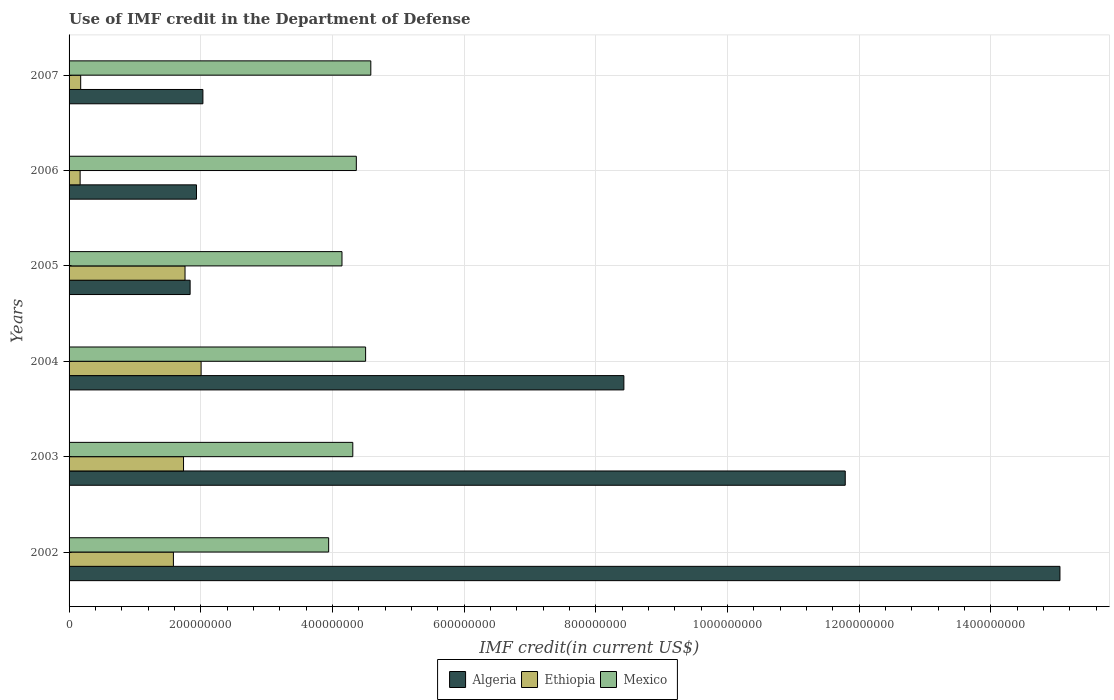How many different coloured bars are there?
Provide a short and direct response. 3. How many groups of bars are there?
Keep it short and to the point. 6. Are the number of bars on each tick of the Y-axis equal?
Make the answer very short. Yes. What is the label of the 1st group of bars from the top?
Ensure brevity in your answer.  2007. In how many cases, is the number of bars for a given year not equal to the number of legend labels?
Provide a succinct answer. 0. What is the IMF credit in the Department of Defense in Ethiopia in 2002?
Your answer should be very brief. 1.58e+08. Across all years, what is the maximum IMF credit in the Department of Defense in Algeria?
Ensure brevity in your answer.  1.51e+09. Across all years, what is the minimum IMF credit in the Department of Defense in Ethiopia?
Provide a short and direct response. 1.68e+07. In which year was the IMF credit in the Department of Defense in Ethiopia maximum?
Offer a terse response. 2004. In which year was the IMF credit in the Department of Defense in Ethiopia minimum?
Provide a succinct answer. 2006. What is the total IMF credit in the Department of Defense in Algeria in the graph?
Offer a terse response. 4.11e+09. What is the difference between the IMF credit in the Department of Defense in Ethiopia in 2002 and that in 2007?
Keep it short and to the point. 1.41e+08. What is the difference between the IMF credit in the Department of Defense in Algeria in 2004 and the IMF credit in the Department of Defense in Mexico in 2006?
Offer a terse response. 4.06e+08. What is the average IMF credit in the Department of Defense in Algeria per year?
Make the answer very short. 6.85e+08. In the year 2005, what is the difference between the IMF credit in the Department of Defense in Algeria and IMF credit in the Department of Defense in Mexico?
Offer a very short reply. -2.31e+08. What is the ratio of the IMF credit in the Department of Defense in Mexico in 2002 to that in 2005?
Offer a very short reply. 0.95. What is the difference between the highest and the second highest IMF credit in the Department of Defense in Algeria?
Ensure brevity in your answer.  3.26e+08. What is the difference between the highest and the lowest IMF credit in the Department of Defense in Algeria?
Give a very brief answer. 1.32e+09. In how many years, is the IMF credit in the Department of Defense in Mexico greater than the average IMF credit in the Department of Defense in Mexico taken over all years?
Your answer should be compact. 4. Is the sum of the IMF credit in the Department of Defense in Algeria in 2005 and 2006 greater than the maximum IMF credit in the Department of Defense in Mexico across all years?
Your answer should be very brief. No. What does the 2nd bar from the top in 2003 represents?
Your response must be concise. Ethiopia. What does the 3rd bar from the bottom in 2005 represents?
Give a very brief answer. Mexico. Is it the case that in every year, the sum of the IMF credit in the Department of Defense in Mexico and IMF credit in the Department of Defense in Algeria is greater than the IMF credit in the Department of Defense in Ethiopia?
Ensure brevity in your answer.  Yes. What is the difference between two consecutive major ticks on the X-axis?
Your answer should be very brief. 2.00e+08. Does the graph contain any zero values?
Provide a short and direct response. No. Where does the legend appear in the graph?
Provide a succinct answer. Bottom center. What is the title of the graph?
Give a very brief answer. Use of IMF credit in the Department of Defense. Does "Burundi" appear as one of the legend labels in the graph?
Your answer should be compact. No. What is the label or title of the X-axis?
Give a very brief answer. IMF credit(in current US$). What is the IMF credit(in current US$) of Algeria in 2002?
Your answer should be compact. 1.51e+09. What is the IMF credit(in current US$) in Ethiopia in 2002?
Ensure brevity in your answer.  1.58e+08. What is the IMF credit(in current US$) of Mexico in 2002?
Offer a very short reply. 3.94e+08. What is the IMF credit(in current US$) in Algeria in 2003?
Provide a short and direct response. 1.18e+09. What is the IMF credit(in current US$) of Ethiopia in 2003?
Offer a terse response. 1.74e+08. What is the IMF credit(in current US$) in Mexico in 2003?
Provide a succinct answer. 4.31e+08. What is the IMF credit(in current US$) of Algeria in 2004?
Your answer should be very brief. 8.43e+08. What is the IMF credit(in current US$) of Ethiopia in 2004?
Your answer should be very brief. 2.01e+08. What is the IMF credit(in current US$) of Mexico in 2004?
Provide a succinct answer. 4.50e+08. What is the IMF credit(in current US$) in Algeria in 2005?
Make the answer very short. 1.84e+08. What is the IMF credit(in current US$) of Ethiopia in 2005?
Give a very brief answer. 1.76e+08. What is the IMF credit(in current US$) in Mexico in 2005?
Offer a terse response. 4.15e+08. What is the IMF credit(in current US$) in Algeria in 2006?
Your answer should be compact. 1.94e+08. What is the IMF credit(in current US$) of Ethiopia in 2006?
Give a very brief answer. 1.68e+07. What is the IMF credit(in current US$) in Mexico in 2006?
Make the answer very short. 4.36e+08. What is the IMF credit(in current US$) in Algeria in 2007?
Offer a terse response. 2.03e+08. What is the IMF credit(in current US$) in Ethiopia in 2007?
Ensure brevity in your answer.  1.76e+07. What is the IMF credit(in current US$) of Mexico in 2007?
Your response must be concise. 4.58e+08. Across all years, what is the maximum IMF credit(in current US$) in Algeria?
Your answer should be compact. 1.51e+09. Across all years, what is the maximum IMF credit(in current US$) of Ethiopia?
Provide a short and direct response. 2.01e+08. Across all years, what is the maximum IMF credit(in current US$) of Mexico?
Make the answer very short. 4.58e+08. Across all years, what is the minimum IMF credit(in current US$) of Algeria?
Ensure brevity in your answer.  1.84e+08. Across all years, what is the minimum IMF credit(in current US$) in Ethiopia?
Your answer should be very brief. 1.68e+07. Across all years, what is the minimum IMF credit(in current US$) in Mexico?
Make the answer very short. 3.94e+08. What is the total IMF credit(in current US$) in Algeria in the graph?
Keep it short and to the point. 4.11e+09. What is the total IMF credit(in current US$) of Ethiopia in the graph?
Provide a short and direct response. 7.43e+08. What is the total IMF credit(in current US$) in Mexico in the graph?
Make the answer very short. 2.58e+09. What is the difference between the IMF credit(in current US$) of Algeria in 2002 and that in 2003?
Your answer should be compact. 3.26e+08. What is the difference between the IMF credit(in current US$) in Ethiopia in 2002 and that in 2003?
Keep it short and to the point. -1.54e+07. What is the difference between the IMF credit(in current US$) in Mexico in 2002 and that in 2003?
Offer a terse response. -3.67e+07. What is the difference between the IMF credit(in current US$) in Algeria in 2002 and that in 2004?
Your answer should be compact. 6.62e+08. What is the difference between the IMF credit(in current US$) of Ethiopia in 2002 and that in 2004?
Your answer should be compact. -4.21e+07. What is the difference between the IMF credit(in current US$) in Mexico in 2002 and that in 2004?
Ensure brevity in your answer.  -5.61e+07. What is the difference between the IMF credit(in current US$) of Algeria in 2002 and that in 2005?
Keep it short and to the point. 1.32e+09. What is the difference between the IMF credit(in current US$) in Ethiopia in 2002 and that in 2005?
Your response must be concise. -1.76e+07. What is the difference between the IMF credit(in current US$) of Mexico in 2002 and that in 2005?
Your answer should be very brief. -2.02e+07. What is the difference between the IMF credit(in current US$) in Algeria in 2002 and that in 2006?
Your response must be concise. 1.31e+09. What is the difference between the IMF credit(in current US$) of Ethiopia in 2002 and that in 2006?
Your answer should be compact. 1.42e+08. What is the difference between the IMF credit(in current US$) in Mexico in 2002 and that in 2006?
Make the answer very short. -4.20e+07. What is the difference between the IMF credit(in current US$) in Algeria in 2002 and that in 2007?
Ensure brevity in your answer.  1.30e+09. What is the difference between the IMF credit(in current US$) of Ethiopia in 2002 and that in 2007?
Your answer should be compact. 1.41e+08. What is the difference between the IMF credit(in current US$) of Mexico in 2002 and that in 2007?
Keep it short and to the point. -6.40e+07. What is the difference between the IMF credit(in current US$) in Algeria in 2003 and that in 2004?
Offer a terse response. 3.36e+08. What is the difference between the IMF credit(in current US$) of Ethiopia in 2003 and that in 2004?
Ensure brevity in your answer.  -2.67e+07. What is the difference between the IMF credit(in current US$) of Mexico in 2003 and that in 2004?
Provide a succinct answer. -1.94e+07. What is the difference between the IMF credit(in current US$) in Algeria in 2003 and that in 2005?
Provide a short and direct response. 9.95e+08. What is the difference between the IMF credit(in current US$) in Ethiopia in 2003 and that in 2005?
Your answer should be compact. -2.28e+06. What is the difference between the IMF credit(in current US$) of Mexico in 2003 and that in 2005?
Offer a very short reply. 1.64e+07. What is the difference between the IMF credit(in current US$) in Algeria in 2003 and that in 2006?
Your answer should be very brief. 9.85e+08. What is the difference between the IMF credit(in current US$) of Ethiopia in 2003 and that in 2006?
Ensure brevity in your answer.  1.57e+08. What is the difference between the IMF credit(in current US$) in Mexico in 2003 and that in 2006?
Make the answer very short. -5.34e+06. What is the difference between the IMF credit(in current US$) of Algeria in 2003 and that in 2007?
Ensure brevity in your answer.  9.76e+08. What is the difference between the IMF credit(in current US$) of Ethiopia in 2003 and that in 2007?
Offer a terse response. 1.56e+08. What is the difference between the IMF credit(in current US$) in Mexico in 2003 and that in 2007?
Your response must be concise. -2.73e+07. What is the difference between the IMF credit(in current US$) of Algeria in 2004 and that in 2005?
Your answer should be compact. 6.59e+08. What is the difference between the IMF credit(in current US$) in Ethiopia in 2004 and that in 2005?
Your answer should be compact. 2.44e+07. What is the difference between the IMF credit(in current US$) in Mexico in 2004 and that in 2005?
Your answer should be very brief. 3.59e+07. What is the difference between the IMF credit(in current US$) of Algeria in 2004 and that in 2006?
Give a very brief answer. 6.49e+08. What is the difference between the IMF credit(in current US$) in Ethiopia in 2004 and that in 2006?
Keep it short and to the point. 1.84e+08. What is the difference between the IMF credit(in current US$) in Mexico in 2004 and that in 2006?
Ensure brevity in your answer.  1.41e+07. What is the difference between the IMF credit(in current US$) in Algeria in 2004 and that in 2007?
Provide a succinct answer. 6.39e+08. What is the difference between the IMF credit(in current US$) of Ethiopia in 2004 and that in 2007?
Make the answer very short. 1.83e+08. What is the difference between the IMF credit(in current US$) of Mexico in 2004 and that in 2007?
Offer a very short reply. -7.90e+06. What is the difference between the IMF credit(in current US$) of Algeria in 2005 and that in 2006?
Your answer should be very brief. -9.66e+06. What is the difference between the IMF credit(in current US$) in Ethiopia in 2005 and that in 2006?
Offer a terse response. 1.59e+08. What is the difference between the IMF credit(in current US$) of Mexico in 2005 and that in 2006?
Your answer should be compact. -2.18e+07. What is the difference between the IMF credit(in current US$) in Algeria in 2005 and that in 2007?
Keep it short and to the point. -1.94e+07. What is the difference between the IMF credit(in current US$) of Ethiopia in 2005 and that in 2007?
Offer a terse response. 1.58e+08. What is the difference between the IMF credit(in current US$) in Mexico in 2005 and that in 2007?
Your answer should be very brief. -4.38e+07. What is the difference between the IMF credit(in current US$) of Algeria in 2006 and that in 2007?
Make the answer very short. -9.76e+06. What is the difference between the IMF credit(in current US$) in Ethiopia in 2006 and that in 2007?
Offer a very short reply. -8.47e+05. What is the difference between the IMF credit(in current US$) in Mexico in 2006 and that in 2007?
Provide a short and direct response. -2.20e+07. What is the difference between the IMF credit(in current US$) in Algeria in 2002 and the IMF credit(in current US$) in Ethiopia in 2003?
Your response must be concise. 1.33e+09. What is the difference between the IMF credit(in current US$) in Algeria in 2002 and the IMF credit(in current US$) in Mexico in 2003?
Provide a short and direct response. 1.07e+09. What is the difference between the IMF credit(in current US$) in Ethiopia in 2002 and the IMF credit(in current US$) in Mexico in 2003?
Give a very brief answer. -2.72e+08. What is the difference between the IMF credit(in current US$) in Algeria in 2002 and the IMF credit(in current US$) in Ethiopia in 2004?
Give a very brief answer. 1.30e+09. What is the difference between the IMF credit(in current US$) of Algeria in 2002 and the IMF credit(in current US$) of Mexico in 2004?
Your answer should be very brief. 1.05e+09. What is the difference between the IMF credit(in current US$) of Ethiopia in 2002 and the IMF credit(in current US$) of Mexico in 2004?
Provide a short and direct response. -2.92e+08. What is the difference between the IMF credit(in current US$) in Algeria in 2002 and the IMF credit(in current US$) in Ethiopia in 2005?
Offer a very short reply. 1.33e+09. What is the difference between the IMF credit(in current US$) in Algeria in 2002 and the IMF credit(in current US$) in Mexico in 2005?
Your response must be concise. 1.09e+09. What is the difference between the IMF credit(in current US$) of Ethiopia in 2002 and the IMF credit(in current US$) of Mexico in 2005?
Your answer should be compact. -2.56e+08. What is the difference between the IMF credit(in current US$) in Algeria in 2002 and the IMF credit(in current US$) in Ethiopia in 2006?
Provide a short and direct response. 1.49e+09. What is the difference between the IMF credit(in current US$) in Algeria in 2002 and the IMF credit(in current US$) in Mexico in 2006?
Your answer should be compact. 1.07e+09. What is the difference between the IMF credit(in current US$) of Ethiopia in 2002 and the IMF credit(in current US$) of Mexico in 2006?
Your answer should be very brief. -2.78e+08. What is the difference between the IMF credit(in current US$) in Algeria in 2002 and the IMF credit(in current US$) in Ethiopia in 2007?
Your answer should be very brief. 1.49e+09. What is the difference between the IMF credit(in current US$) in Algeria in 2002 and the IMF credit(in current US$) in Mexico in 2007?
Offer a very short reply. 1.05e+09. What is the difference between the IMF credit(in current US$) of Ethiopia in 2002 and the IMF credit(in current US$) of Mexico in 2007?
Give a very brief answer. -3.00e+08. What is the difference between the IMF credit(in current US$) of Algeria in 2003 and the IMF credit(in current US$) of Ethiopia in 2004?
Make the answer very short. 9.78e+08. What is the difference between the IMF credit(in current US$) in Algeria in 2003 and the IMF credit(in current US$) in Mexico in 2004?
Give a very brief answer. 7.29e+08. What is the difference between the IMF credit(in current US$) in Ethiopia in 2003 and the IMF credit(in current US$) in Mexico in 2004?
Your answer should be very brief. -2.77e+08. What is the difference between the IMF credit(in current US$) in Algeria in 2003 and the IMF credit(in current US$) in Ethiopia in 2005?
Offer a very short reply. 1.00e+09. What is the difference between the IMF credit(in current US$) in Algeria in 2003 and the IMF credit(in current US$) in Mexico in 2005?
Your answer should be compact. 7.64e+08. What is the difference between the IMF credit(in current US$) in Ethiopia in 2003 and the IMF credit(in current US$) in Mexico in 2005?
Your answer should be very brief. -2.41e+08. What is the difference between the IMF credit(in current US$) of Algeria in 2003 and the IMF credit(in current US$) of Ethiopia in 2006?
Provide a short and direct response. 1.16e+09. What is the difference between the IMF credit(in current US$) of Algeria in 2003 and the IMF credit(in current US$) of Mexico in 2006?
Provide a succinct answer. 7.43e+08. What is the difference between the IMF credit(in current US$) in Ethiopia in 2003 and the IMF credit(in current US$) in Mexico in 2006?
Provide a succinct answer. -2.62e+08. What is the difference between the IMF credit(in current US$) of Algeria in 2003 and the IMF credit(in current US$) of Ethiopia in 2007?
Your answer should be very brief. 1.16e+09. What is the difference between the IMF credit(in current US$) in Algeria in 2003 and the IMF credit(in current US$) in Mexico in 2007?
Offer a terse response. 7.21e+08. What is the difference between the IMF credit(in current US$) of Ethiopia in 2003 and the IMF credit(in current US$) of Mexico in 2007?
Your answer should be compact. -2.84e+08. What is the difference between the IMF credit(in current US$) of Algeria in 2004 and the IMF credit(in current US$) of Ethiopia in 2005?
Give a very brief answer. 6.67e+08. What is the difference between the IMF credit(in current US$) of Algeria in 2004 and the IMF credit(in current US$) of Mexico in 2005?
Give a very brief answer. 4.28e+08. What is the difference between the IMF credit(in current US$) in Ethiopia in 2004 and the IMF credit(in current US$) in Mexico in 2005?
Your answer should be very brief. -2.14e+08. What is the difference between the IMF credit(in current US$) in Algeria in 2004 and the IMF credit(in current US$) in Ethiopia in 2006?
Keep it short and to the point. 8.26e+08. What is the difference between the IMF credit(in current US$) in Algeria in 2004 and the IMF credit(in current US$) in Mexico in 2006?
Offer a terse response. 4.06e+08. What is the difference between the IMF credit(in current US$) of Ethiopia in 2004 and the IMF credit(in current US$) of Mexico in 2006?
Offer a terse response. -2.36e+08. What is the difference between the IMF credit(in current US$) of Algeria in 2004 and the IMF credit(in current US$) of Ethiopia in 2007?
Provide a short and direct response. 8.25e+08. What is the difference between the IMF credit(in current US$) in Algeria in 2004 and the IMF credit(in current US$) in Mexico in 2007?
Your answer should be compact. 3.84e+08. What is the difference between the IMF credit(in current US$) in Ethiopia in 2004 and the IMF credit(in current US$) in Mexico in 2007?
Make the answer very short. -2.58e+08. What is the difference between the IMF credit(in current US$) in Algeria in 2005 and the IMF credit(in current US$) in Ethiopia in 2006?
Your answer should be compact. 1.67e+08. What is the difference between the IMF credit(in current US$) of Algeria in 2005 and the IMF credit(in current US$) of Mexico in 2006?
Your response must be concise. -2.52e+08. What is the difference between the IMF credit(in current US$) in Ethiopia in 2005 and the IMF credit(in current US$) in Mexico in 2006?
Provide a succinct answer. -2.60e+08. What is the difference between the IMF credit(in current US$) in Algeria in 2005 and the IMF credit(in current US$) in Ethiopia in 2007?
Offer a terse response. 1.66e+08. What is the difference between the IMF credit(in current US$) in Algeria in 2005 and the IMF credit(in current US$) in Mexico in 2007?
Offer a terse response. -2.74e+08. What is the difference between the IMF credit(in current US$) of Ethiopia in 2005 and the IMF credit(in current US$) of Mexico in 2007?
Your answer should be compact. -2.82e+08. What is the difference between the IMF credit(in current US$) in Algeria in 2006 and the IMF credit(in current US$) in Ethiopia in 2007?
Ensure brevity in your answer.  1.76e+08. What is the difference between the IMF credit(in current US$) of Algeria in 2006 and the IMF credit(in current US$) of Mexico in 2007?
Provide a short and direct response. -2.65e+08. What is the difference between the IMF credit(in current US$) in Ethiopia in 2006 and the IMF credit(in current US$) in Mexico in 2007?
Make the answer very short. -4.42e+08. What is the average IMF credit(in current US$) of Algeria per year?
Your answer should be very brief. 6.85e+08. What is the average IMF credit(in current US$) in Ethiopia per year?
Keep it short and to the point. 1.24e+08. What is the average IMF credit(in current US$) of Mexico per year?
Give a very brief answer. 4.31e+08. In the year 2002, what is the difference between the IMF credit(in current US$) in Algeria and IMF credit(in current US$) in Ethiopia?
Give a very brief answer. 1.35e+09. In the year 2002, what is the difference between the IMF credit(in current US$) in Algeria and IMF credit(in current US$) in Mexico?
Your response must be concise. 1.11e+09. In the year 2002, what is the difference between the IMF credit(in current US$) in Ethiopia and IMF credit(in current US$) in Mexico?
Offer a terse response. -2.36e+08. In the year 2003, what is the difference between the IMF credit(in current US$) in Algeria and IMF credit(in current US$) in Ethiopia?
Provide a short and direct response. 1.01e+09. In the year 2003, what is the difference between the IMF credit(in current US$) in Algeria and IMF credit(in current US$) in Mexico?
Your answer should be very brief. 7.48e+08. In the year 2003, what is the difference between the IMF credit(in current US$) in Ethiopia and IMF credit(in current US$) in Mexico?
Ensure brevity in your answer.  -2.57e+08. In the year 2004, what is the difference between the IMF credit(in current US$) in Algeria and IMF credit(in current US$) in Ethiopia?
Your answer should be compact. 6.42e+08. In the year 2004, what is the difference between the IMF credit(in current US$) of Algeria and IMF credit(in current US$) of Mexico?
Your answer should be very brief. 3.92e+08. In the year 2004, what is the difference between the IMF credit(in current US$) of Ethiopia and IMF credit(in current US$) of Mexico?
Your response must be concise. -2.50e+08. In the year 2005, what is the difference between the IMF credit(in current US$) in Algeria and IMF credit(in current US$) in Ethiopia?
Your answer should be compact. 7.73e+06. In the year 2005, what is the difference between the IMF credit(in current US$) of Algeria and IMF credit(in current US$) of Mexico?
Make the answer very short. -2.31e+08. In the year 2005, what is the difference between the IMF credit(in current US$) in Ethiopia and IMF credit(in current US$) in Mexico?
Provide a short and direct response. -2.38e+08. In the year 2006, what is the difference between the IMF credit(in current US$) of Algeria and IMF credit(in current US$) of Ethiopia?
Your answer should be compact. 1.77e+08. In the year 2006, what is the difference between the IMF credit(in current US$) of Algeria and IMF credit(in current US$) of Mexico?
Give a very brief answer. -2.43e+08. In the year 2006, what is the difference between the IMF credit(in current US$) in Ethiopia and IMF credit(in current US$) in Mexico?
Your response must be concise. -4.20e+08. In the year 2007, what is the difference between the IMF credit(in current US$) of Algeria and IMF credit(in current US$) of Ethiopia?
Provide a succinct answer. 1.86e+08. In the year 2007, what is the difference between the IMF credit(in current US$) of Algeria and IMF credit(in current US$) of Mexico?
Provide a succinct answer. -2.55e+08. In the year 2007, what is the difference between the IMF credit(in current US$) in Ethiopia and IMF credit(in current US$) in Mexico?
Keep it short and to the point. -4.41e+08. What is the ratio of the IMF credit(in current US$) in Algeria in 2002 to that in 2003?
Your response must be concise. 1.28. What is the ratio of the IMF credit(in current US$) in Ethiopia in 2002 to that in 2003?
Provide a short and direct response. 0.91. What is the ratio of the IMF credit(in current US$) of Mexico in 2002 to that in 2003?
Give a very brief answer. 0.91. What is the ratio of the IMF credit(in current US$) of Algeria in 2002 to that in 2004?
Your response must be concise. 1.79. What is the ratio of the IMF credit(in current US$) in Ethiopia in 2002 to that in 2004?
Ensure brevity in your answer.  0.79. What is the ratio of the IMF credit(in current US$) in Mexico in 2002 to that in 2004?
Give a very brief answer. 0.88. What is the ratio of the IMF credit(in current US$) in Algeria in 2002 to that in 2005?
Offer a very short reply. 8.19. What is the ratio of the IMF credit(in current US$) in Ethiopia in 2002 to that in 2005?
Your response must be concise. 0.9. What is the ratio of the IMF credit(in current US$) of Mexico in 2002 to that in 2005?
Your response must be concise. 0.95. What is the ratio of the IMF credit(in current US$) in Algeria in 2002 to that in 2006?
Your response must be concise. 7.78. What is the ratio of the IMF credit(in current US$) of Ethiopia in 2002 to that in 2006?
Provide a short and direct response. 9.44. What is the ratio of the IMF credit(in current US$) in Mexico in 2002 to that in 2006?
Provide a succinct answer. 0.9. What is the ratio of the IMF credit(in current US$) in Algeria in 2002 to that in 2007?
Offer a terse response. 7.4. What is the ratio of the IMF credit(in current US$) of Ethiopia in 2002 to that in 2007?
Your answer should be very brief. 8.99. What is the ratio of the IMF credit(in current US$) in Mexico in 2002 to that in 2007?
Your answer should be very brief. 0.86. What is the ratio of the IMF credit(in current US$) of Algeria in 2003 to that in 2004?
Keep it short and to the point. 1.4. What is the ratio of the IMF credit(in current US$) of Ethiopia in 2003 to that in 2004?
Keep it short and to the point. 0.87. What is the ratio of the IMF credit(in current US$) in Mexico in 2003 to that in 2004?
Offer a very short reply. 0.96. What is the ratio of the IMF credit(in current US$) of Algeria in 2003 to that in 2005?
Offer a very short reply. 6.41. What is the ratio of the IMF credit(in current US$) in Mexico in 2003 to that in 2005?
Provide a short and direct response. 1.04. What is the ratio of the IMF credit(in current US$) of Algeria in 2003 to that in 2006?
Your answer should be compact. 6.09. What is the ratio of the IMF credit(in current US$) of Ethiopia in 2003 to that in 2006?
Your answer should be compact. 10.35. What is the ratio of the IMF credit(in current US$) of Algeria in 2003 to that in 2007?
Make the answer very short. 5.8. What is the ratio of the IMF credit(in current US$) of Ethiopia in 2003 to that in 2007?
Make the answer very short. 9.86. What is the ratio of the IMF credit(in current US$) in Mexico in 2003 to that in 2007?
Offer a very short reply. 0.94. What is the ratio of the IMF credit(in current US$) in Algeria in 2004 to that in 2005?
Offer a very short reply. 4.58. What is the ratio of the IMF credit(in current US$) of Ethiopia in 2004 to that in 2005?
Offer a very short reply. 1.14. What is the ratio of the IMF credit(in current US$) in Mexico in 2004 to that in 2005?
Your answer should be compact. 1.09. What is the ratio of the IMF credit(in current US$) of Algeria in 2004 to that in 2006?
Give a very brief answer. 4.35. What is the ratio of the IMF credit(in current US$) of Ethiopia in 2004 to that in 2006?
Make the answer very short. 11.94. What is the ratio of the IMF credit(in current US$) in Mexico in 2004 to that in 2006?
Provide a succinct answer. 1.03. What is the ratio of the IMF credit(in current US$) in Algeria in 2004 to that in 2007?
Give a very brief answer. 4.15. What is the ratio of the IMF credit(in current US$) of Ethiopia in 2004 to that in 2007?
Offer a terse response. 11.37. What is the ratio of the IMF credit(in current US$) of Mexico in 2004 to that in 2007?
Give a very brief answer. 0.98. What is the ratio of the IMF credit(in current US$) in Algeria in 2005 to that in 2006?
Your answer should be compact. 0.95. What is the ratio of the IMF credit(in current US$) in Ethiopia in 2005 to that in 2006?
Offer a very short reply. 10.49. What is the ratio of the IMF credit(in current US$) in Mexico in 2005 to that in 2006?
Your response must be concise. 0.95. What is the ratio of the IMF credit(in current US$) in Algeria in 2005 to that in 2007?
Offer a terse response. 0.9. What is the ratio of the IMF credit(in current US$) in Ethiopia in 2005 to that in 2007?
Provide a succinct answer. 9.99. What is the ratio of the IMF credit(in current US$) of Mexico in 2005 to that in 2007?
Make the answer very short. 0.9. What is the ratio of the IMF credit(in current US$) of Algeria in 2006 to that in 2007?
Your response must be concise. 0.95. What is the difference between the highest and the second highest IMF credit(in current US$) of Algeria?
Your answer should be very brief. 3.26e+08. What is the difference between the highest and the second highest IMF credit(in current US$) of Ethiopia?
Offer a terse response. 2.44e+07. What is the difference between the highest and the second highest IMF credit(in current US$) in Mexico?
Offer a terse response. 7.90e+06. What is the difference between the highest and the lowest IMF credit(in current US$) in Algeria?
Make the answer very short. 1.32e+09. What is the difference between the highest and the lowest IMF credit(in current US$) of Ethiopia?
Provide a short and direct response. 1.84e+08. What is the difference between the highest and the lowest IMF credit(in current US$) of Mexico?
Your response must be concise. 6.40e+07. 